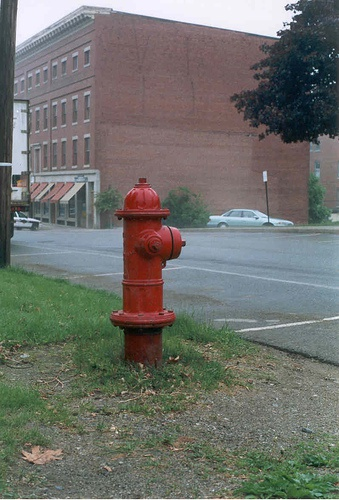Describe the objects in this image and their specific colors. I can see fire hydrant in lightgray, maroon, black, and brown tones, car in lightgray, darkgray, gray, and lightblue tones, and car in lightgray, purple, and darkgray tones in this image. 